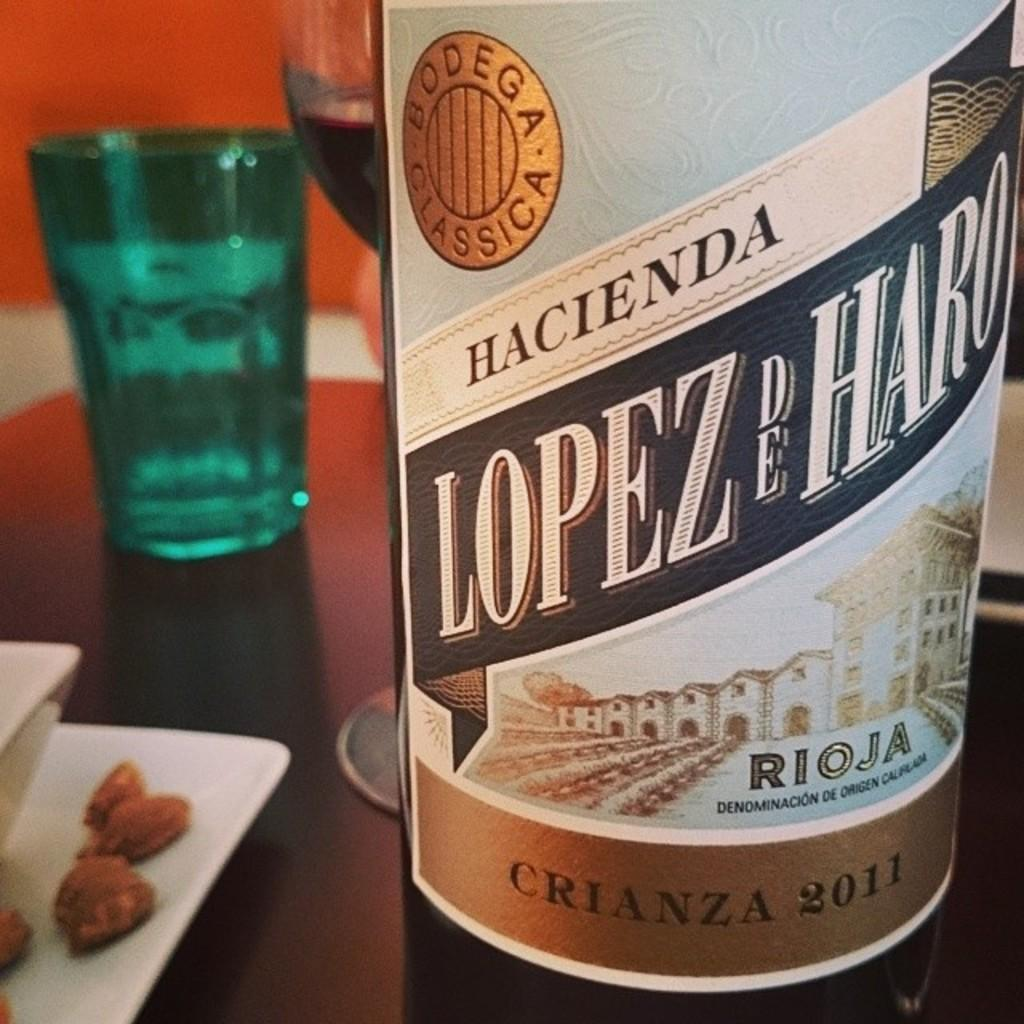<image>
Present a compact description of the photo's key features. A bottle has the word Hacienda on the label. 